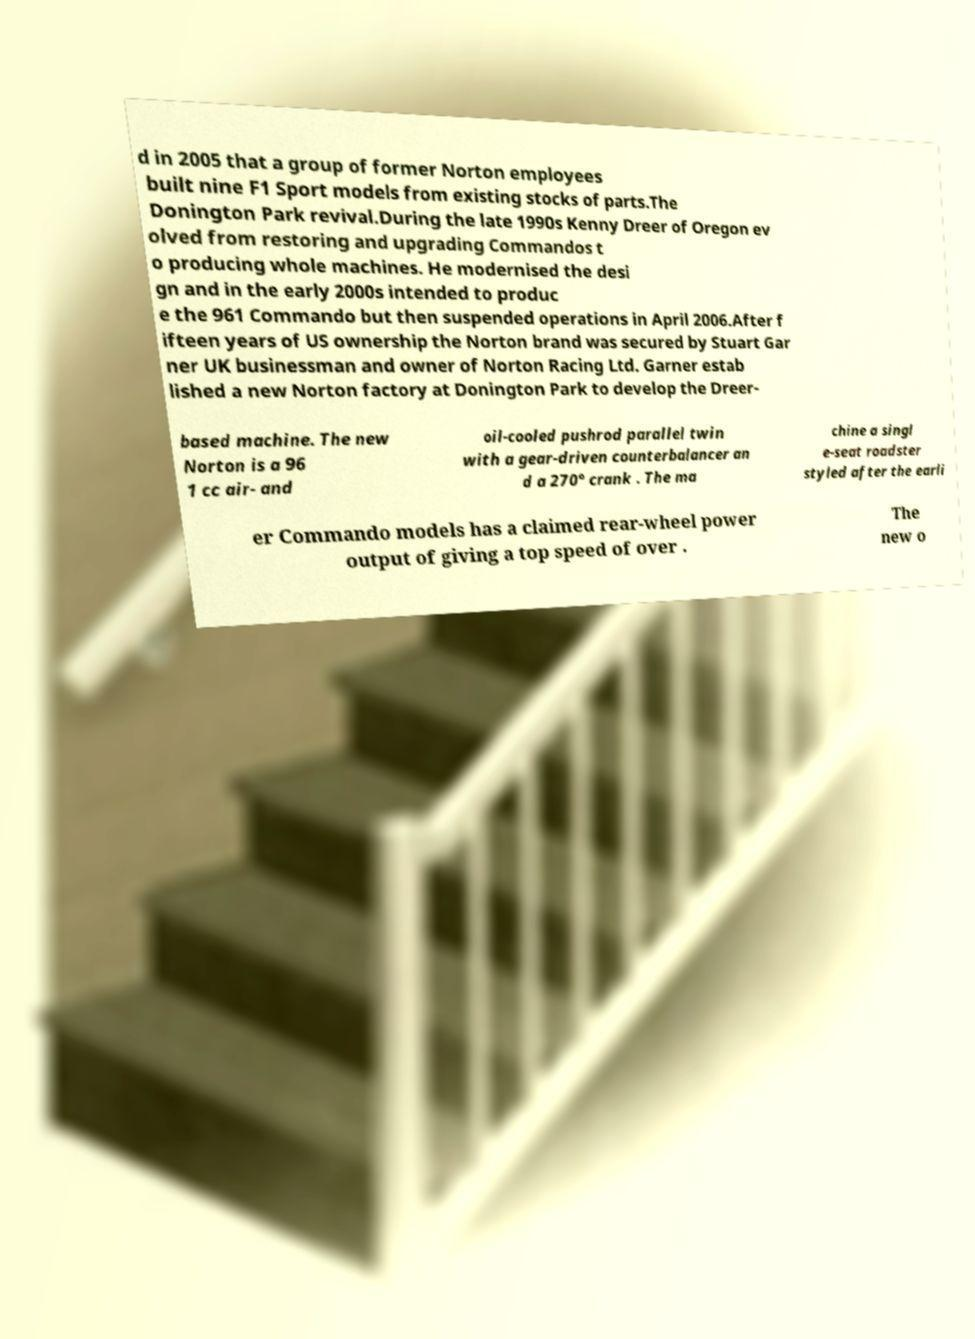Could you extract and type out the text from this image? d in 2005 that a group of former Norton employees built nine F1 Sport models from existing stocks of parts.The Donington Park revival.During the late 1990s Kenny Dreer of Oregon ev olved from restoring and upgrading Commandos t o producing whole machines. He modernised the desi gn and in the early 2000s intended to produc e the 961 Commando but then suspended operations in April 2006.After f ifteen years of US ownership the Norton brand was secured by Stuart Gar ner UK businessman and owner of Norton Racing Ltd. Garner estab lished a new Norton factory at Donington Park to develop the Dreer- based machine. The new Norton is a 96 1 cc air- and oil-cooled pushrod parallel twin with a gear-driven counterbalancer an d a 270° crank . The ma chine a singl e-seat roadster styled after the earli er Commando models has a claimed rear-wheel power output of giving a top speed of over . The new o 